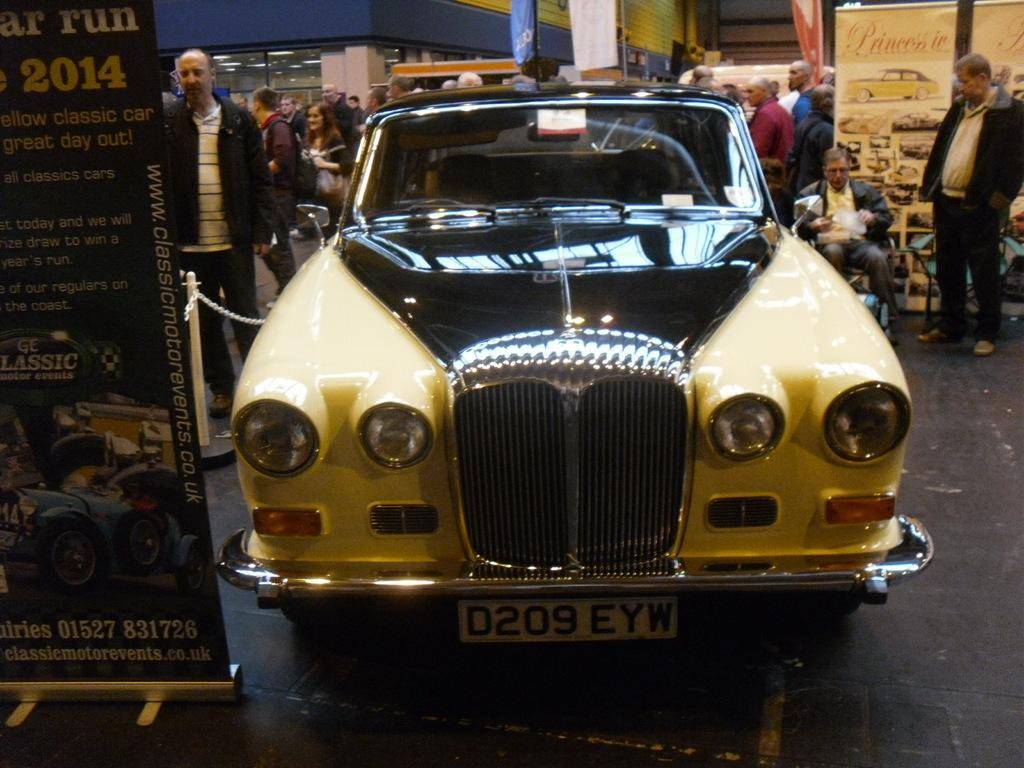<image>
Create a compact narrative representing the image presented. The year 2014 can be seen behind a car on display. 